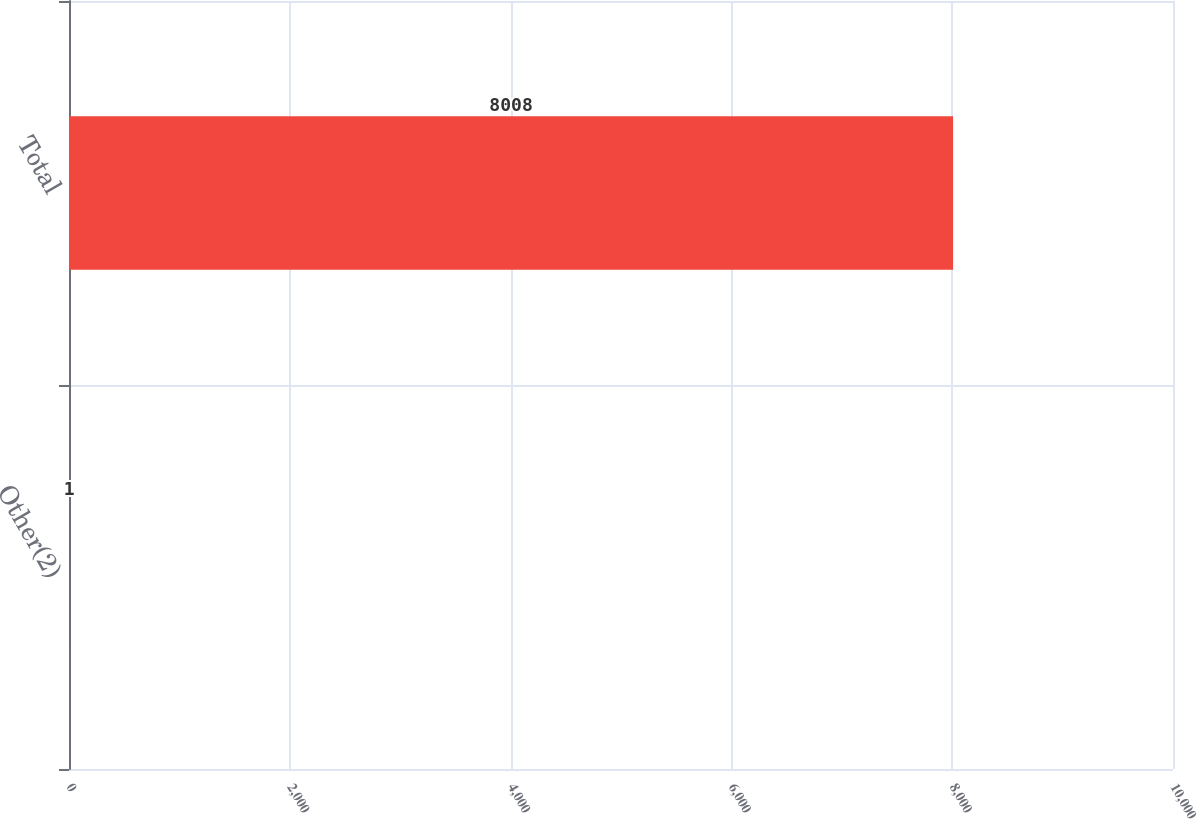Convert chart to OTSL. <chart><loc_0><loc_0><loc_500><loc_500><bar_chart><fcel>Other(2)<fcel>Total<nl><fcel>1<fcel>8008<nl></chart> 